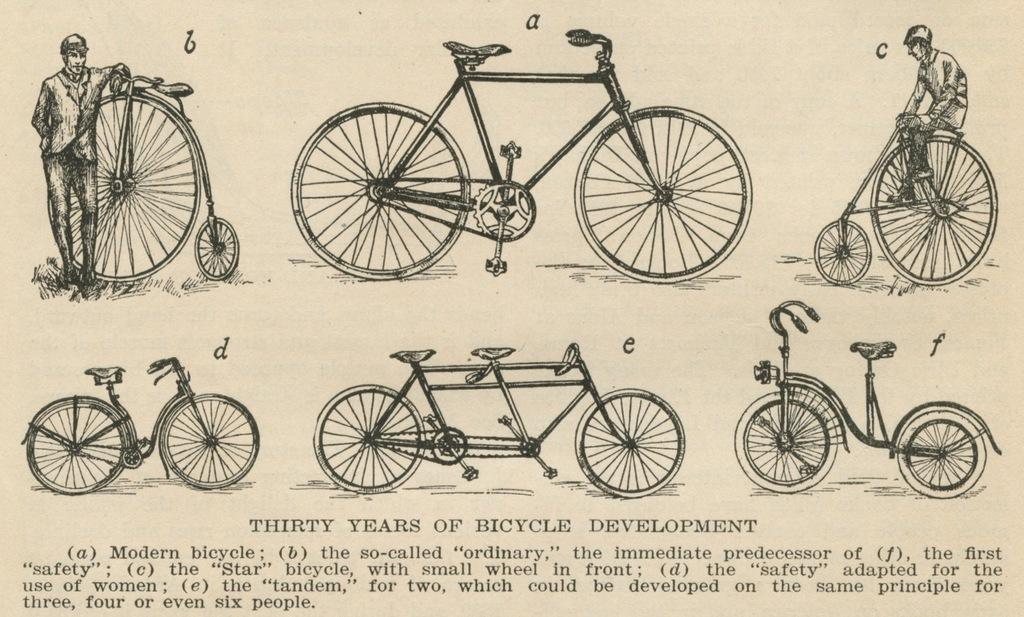What is featured in the image? There is a poster in the image. What is depicted on the poster? The poster contains different types of bicycles. Is there any text on the poster? Yes, there is text on the poster. Can you see a monkey swinging from a tree on the poster? No, there is no monkey or tree present on the poster; it features different types of bicycles and text. 